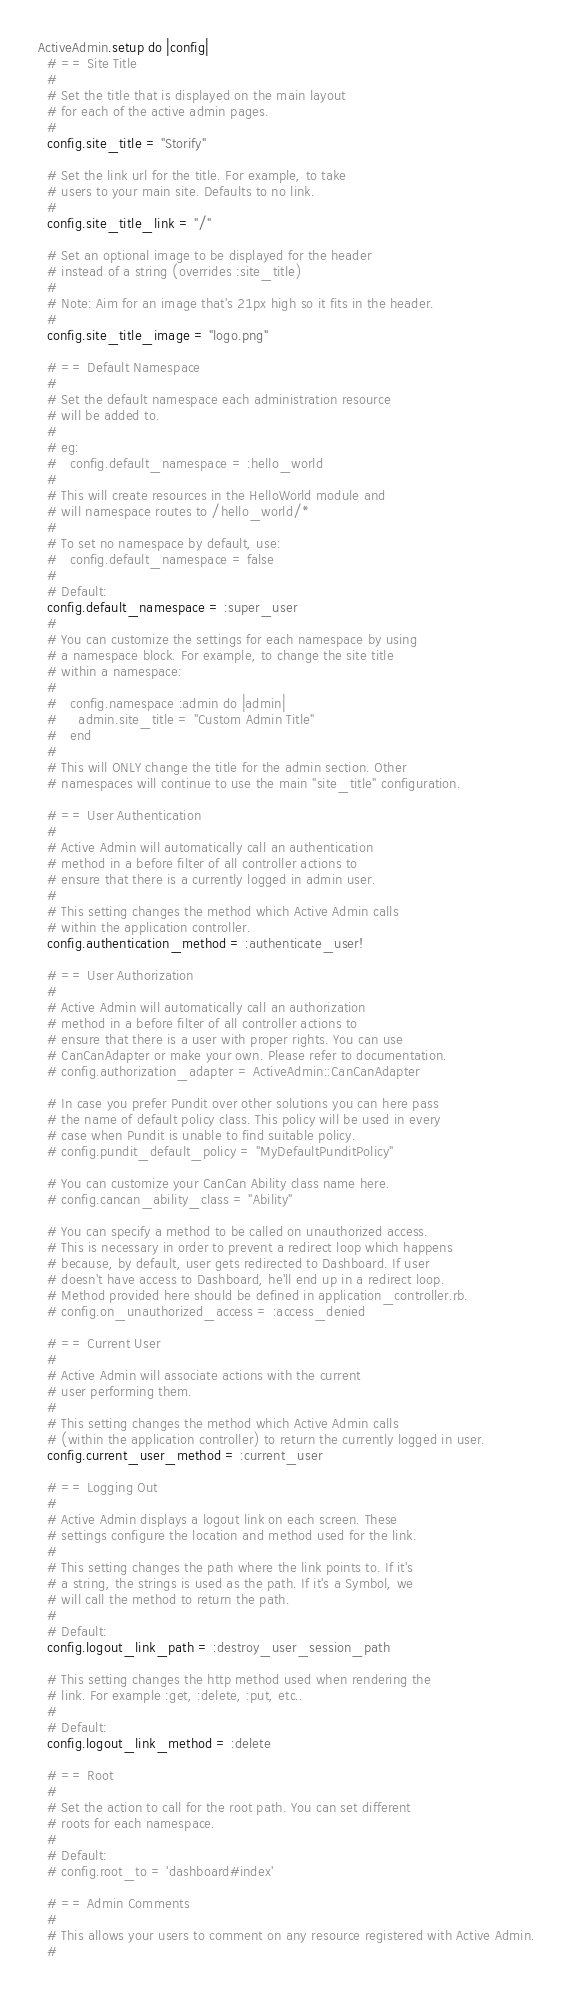Convert code to text. <code><loc_0><loc_0><loc_500><loc_500><_Ruby_>ActiveAdmin.setup do |config|
  # == Site Title
  #
  # Set the title that is displayed on the main layout
  # for each of the active admin pages.
  #
  config.site_title = "Storify"

  # Set the link url for the title. For example, to take
  # users to your main site. Defaults to no link.
  #
  config.site_title_link = "/"

  # Set an optional image to be displayed for the header
  # instead of a string (overrides :site_title)
  #
  # Note: Aim for an image that's 21px high so it fits in the header.
  #
  config.site_title_image = "logo.png"

  # == Default Namespace
  #
  # Set the default namespace each administration resource
  # will be added to.
  #
  # eg:
  #   config.default_namespace = :hello_world
  #
  # This will create resources in the HelloWorld module and
  # will namespace routes to /hello_world/*
  #
  # To set no namespace by default, use:
  #   config.default_namespace = false
  #
  # Default:
  config.default_namespace = :super_user
  #
  # You can customize the settings for each namespace by using
  # a namespace block. For example, to change the site title
  # within a namespace:
  #
  #   config.namespace :admin do |admin|
  #     admin.site_title = "Custom Admin Title"
  #   end
  #
  # This will ONLY change the title for the admin section. Other
  # namespaces will continue to use the main "site_title" configuration.

  # == User Authentication
  #
  # Active Admin will automatically call an authentication
  # method in a before filter of all controller actions to
  # ensure that there is a currently logged in admin user.
  #
  # This setting changes the method which Active Admin calls
  # within the application controller.
  config.authentication_method = :authenticate_user!

  # == User Authorization
  #
  # Active Admin will automatically call an authorization
  # method in a before filter of all controller actions to
  # ensure that there is a user with proper rights. You can use
  # CanCanAdapter or make your own. Please refer to documentation.
  # config.authorization_adapter = ActiveAdmin::CanCanAdapter

  # In case you prefer Pundit over other solutions you can here pass
  # the name of default policy class. This policy will be used in every
  # case when Pundit is unable to find suitable policy.
  # config.pundit_default_policy = "MyDefaultPunditPolicy"

  # You can customize your CanCan Ability class name here.
  # config.cancan_ability_class = "Ability"

  # You can specify a method to be called on unauthorized access.
  # This is necessary in order to prevent a redirect loop which happens
  # because, by default, user gets redirected to Dashboard. If user
  # doesn't have access to Dashboard, he'll end up in a redirect loop.
  # Method provided here should be defined in application_controller.rb.
  # config.on_unauthorized_access = :access_denied

  # == Current User
  #
  # Active Admin will associate actions with the current
  # user performing them.
  #
  # This setting changes the method which Active Admin calls
  # (within the application controller) to return the currently logged in user.
  config.current_user_method = :current_user

  # == Logging Out
  #
  # Active Admin displays a logout link on each screen. These
  # settings configure the location and method used for the link.
  #
  # This setting changes the path where the link points to. If it's
  # a string, the strings is used as the path. If it's a Symbol, we
  # will call the method to return the path.
  #
  # Default:
  config.logout_link_path = :destroy_user_session_path

  # This setting changes the http method used when rendering the
  # link. For example :get, :delete, :put, etc..
  #
  # Default:
  config.logout_link_method = :delete

  # == Root
  #
  # Set the action to call for the root path. You can set different
  # roots for each namespace.
  #
  # Default:
  # config.root_to = 'dashboard#index'

  # == Admin Comments
  #
  # This allows your users to comment on any resource registered with Active Admin.
  #</code> 